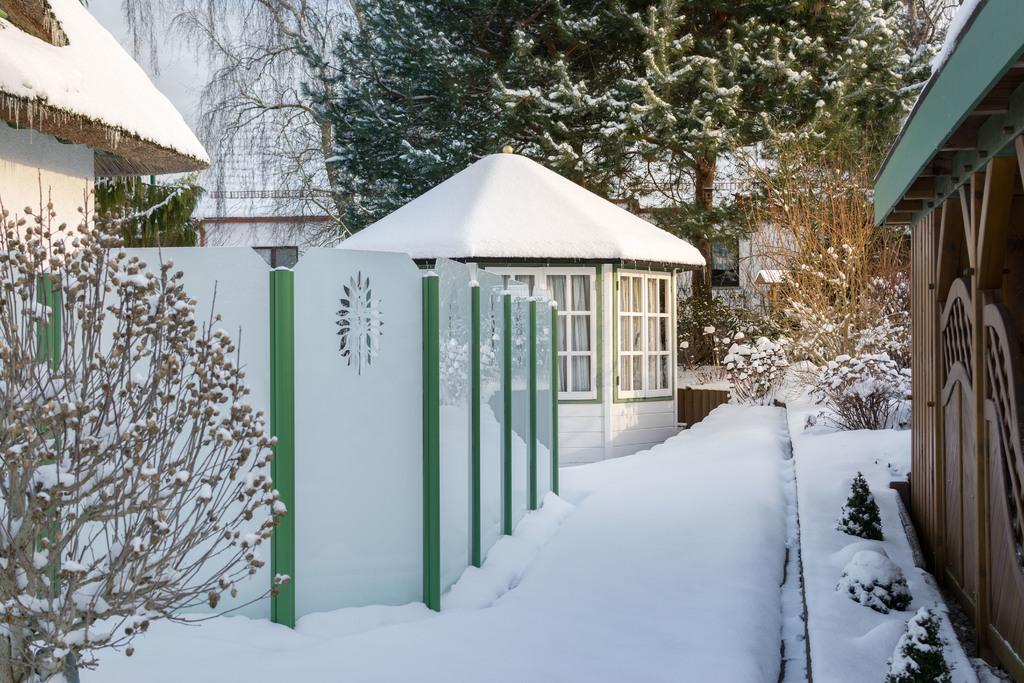In one or two sentences, can you explain what this image depicts? At the bottom of the picture, we see ice. On the left side, we see a tree and a building which is covered with ice. In the middle of the picture, we see a hut is covered with ice. In the background, there are buildings, trees and plants, which are covered with ice. On the right side, we see a building in brown and green color. 